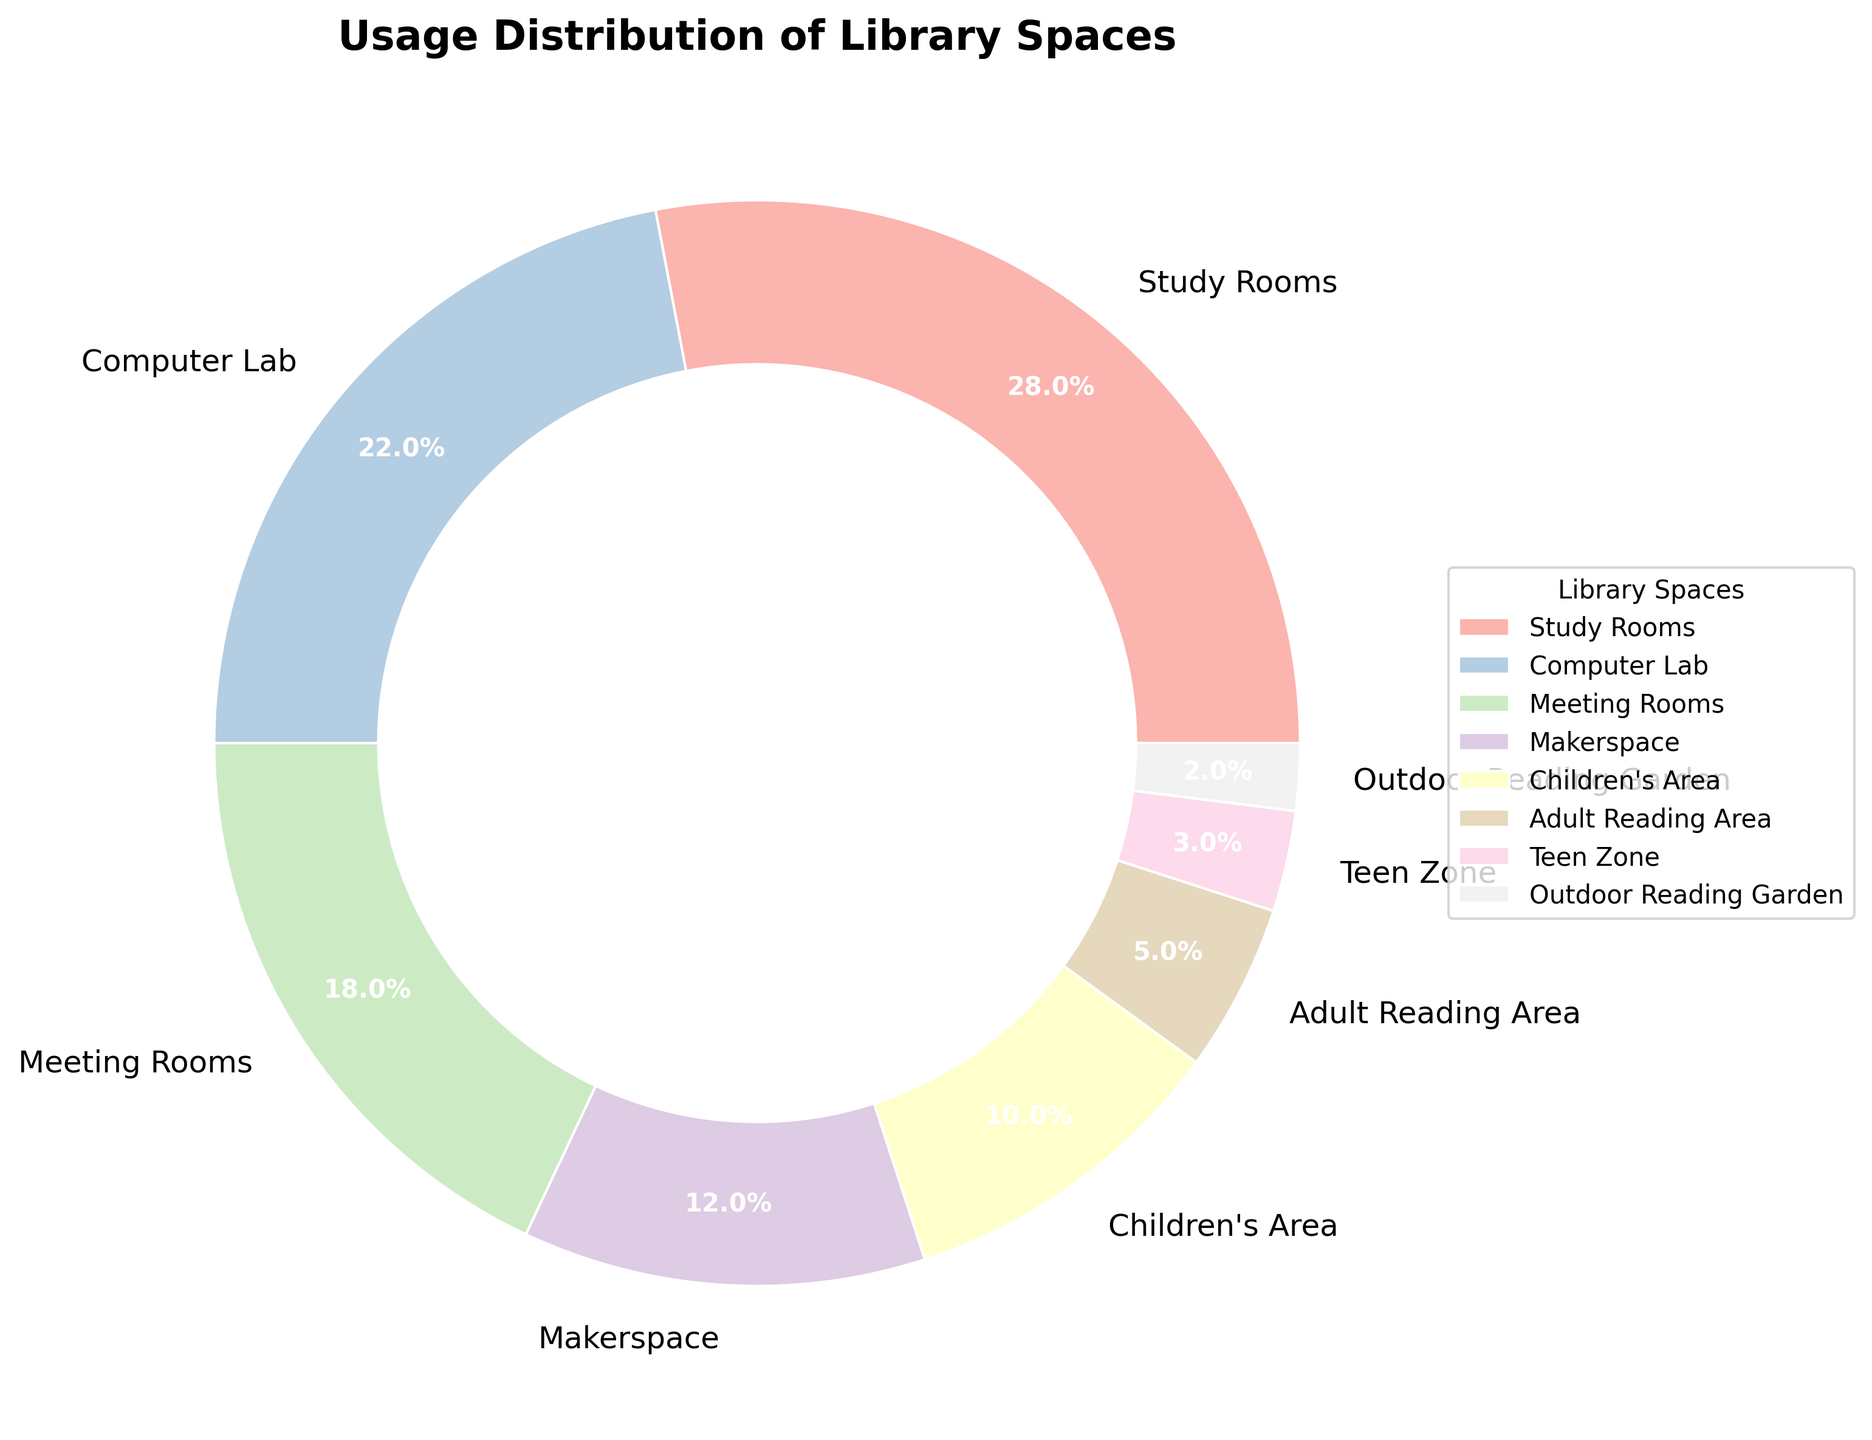Which library space has the highest usage percentage? The figure shows the usage distribution of different library spaces. The wedge for Study Rooms is the largest and displays a percentage of 28%, making it the highest.
Answer: Study Rooms Which space has a lower usage percentage, Children's Area or Teen Zone? By observing the figure, the Children's Area has a usage percentage of 10%, while the Teen Zone has a smaller wedge with 3%. Thus, the Teen Zone has a lower percentage.
Answer: Teen Zone What is the combined usage percentage of the Adult Reading Area and Outdoor Reading Garden? The Adult Reading Area has a usage percentage of 5%, and the Outdoor Reading Garden has 2%. Adding these percentages gives 5% + 2% = 7%.
Answer: 7% How much higher is the usage percentage of the Computer Lab compared to the Makerspace? The Computer Lab has a usage percentage of 22%, while the Makerspace has 12%. The difference is 22% - 12% = 10%.
Answer: 10% What is the second most used library space? According to the figure, the Study Rooms are the most used at 28%, followed by the Computer Lab at 22%, making it the second most used space.
Answer: Computer Lab What's the percentage difference between the most and least used spaces? The most used space is the Study Rooms at 28%, and the least used space is the Outdoor Reading Garden at 2%. The difference is 28% - 2% = 26%.
Answer: 26% Which library spaces cumulatively make up more than 50% of the usage? From the figure, the Study Rooms (28%) and Computer Lab (22%) collectively add up to 28% + 22% = 50%, reaching more than half of the total usage.
Answer: Study Rooms and Computer Lab How does the usage of the Meeting Rooms compare to the Children's Area? The Meeting Rooms have a usage percentage of 18%, while the Children's Area has a usage percentage of 10%. Therefore, Meeting Rooms have a higher usage.
Answer: Meeting Rooms have higher usage What portion of the library's usage is dedicated to all the spaces not intended for study or meeting purposes? Excluding Study Rooms (28%), Computer Lab (22%), Meeting Rooms (18%), the remaining percentages are Makerspace (12%), Children's Area (10%), Adult Reading Area (5%), Teen Zone (3%), and Outdoor Reading Garden (2%), which sum up to 12% + 10% + 5% + 3% + 2% = 32%.
Answer: 32% Which library space has half the usage percentage of the Computer Lab? The Computer Lab has a usage percentage of 22%. Half of 22% is 11%. From the chart, the closest space is the Makerspace with 12%, although not exactly half, it's the nearest.
Answer: Makerspace (nearest) 